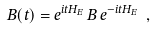<formula> <loc_0><loc_0><loc_500><loc_500>B ( t ) = e ^ { i t H _ { E } } \, B \, e ^ { - i t H _ { E } } \ ,</formula> 